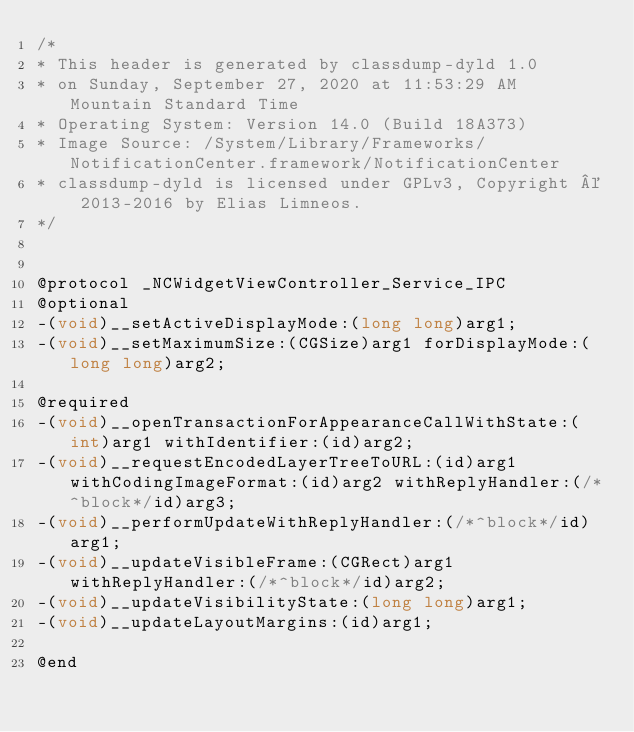<code> <loc_0><loc_0><loc_500><loc_500><_C_>/*
* This header is generated by classdump-dyld 1.0
* on Sunday, September 27, 2020 at 11:53:29 AM Mountain Standard Time
* Operating System: Version 14.0 (Build 18A373)
* Image Source: /System/Library/Frameworks/NotificationCenter.framework/NotificationCenter
* classdump-dyld is licensed under GPLv3, Copyright © 2013-2016 by Elias Limneos.
*/


@protocol _NCWidgetViewController_Service_IPC
@optional
-(void)__setActiveDisplayMode:(long long)arg1;
-(void)__setMaximumSize:(CGSize)arg1 forDisplayMode:(long long)arg2;

@required
-(void)__openTransactionForAppearanceCallWithState:(int)arg1 withIdentifier:(id)arg2;
-(void)__requestEncodedLayerTreeToURL:(id)arg1 withCodingImageFormat:(id)arg2 withReplyHandler:(/*^block*/id)arg3;
-(void)__performUpdateWithReplyHandler:(/*^block*/id)arg1;
-(void)__updateVisibleFrame:(CGRect)arg1 withReplyHandler:(/*^block*/id)arg2;
-(void)__updateVisibilityState:(long long)arg1;
-(void)__updateLayoutMargins:(id)arg1;

@end

</code> 